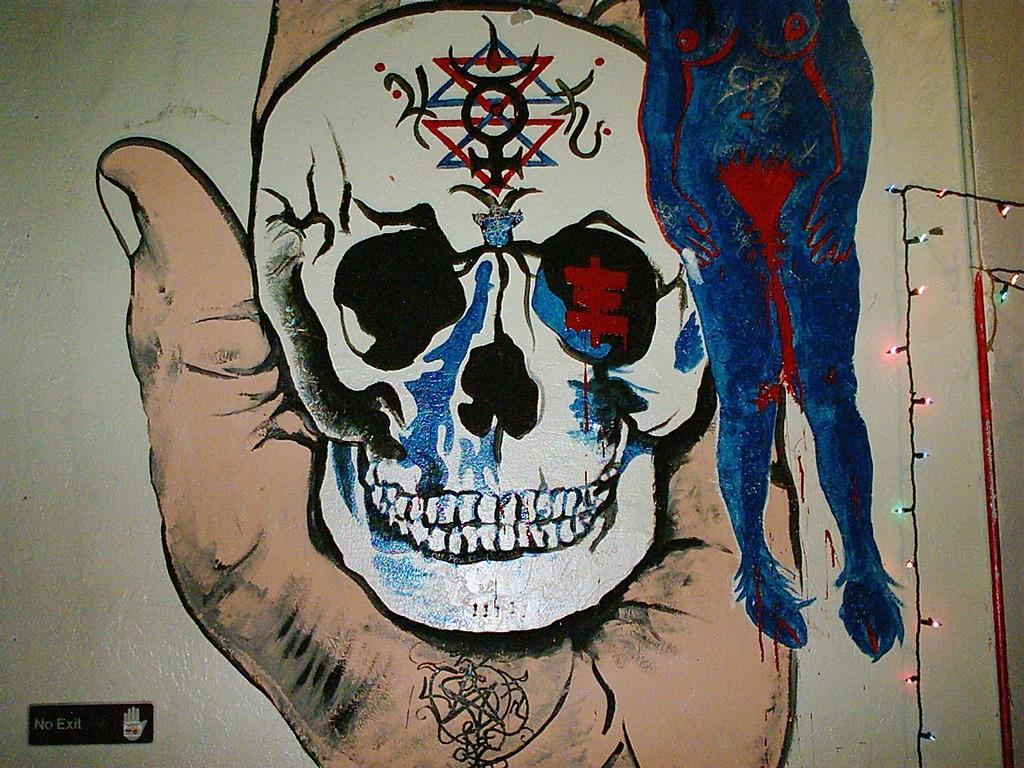What is depicted on the wall in the image? There is a painting on the wall in the image. What can be seen providing illumination in the image? There are lights visible in the image. What type of object can be seen in the image that might be used for transporting fluids? There is a pipe in the image. What type of jewel is the person wearing in the image? There is no person visible in the image, and therefore no jewelry can be observed. What type of health advice is being given in the image? There is no health advice present in the image. 